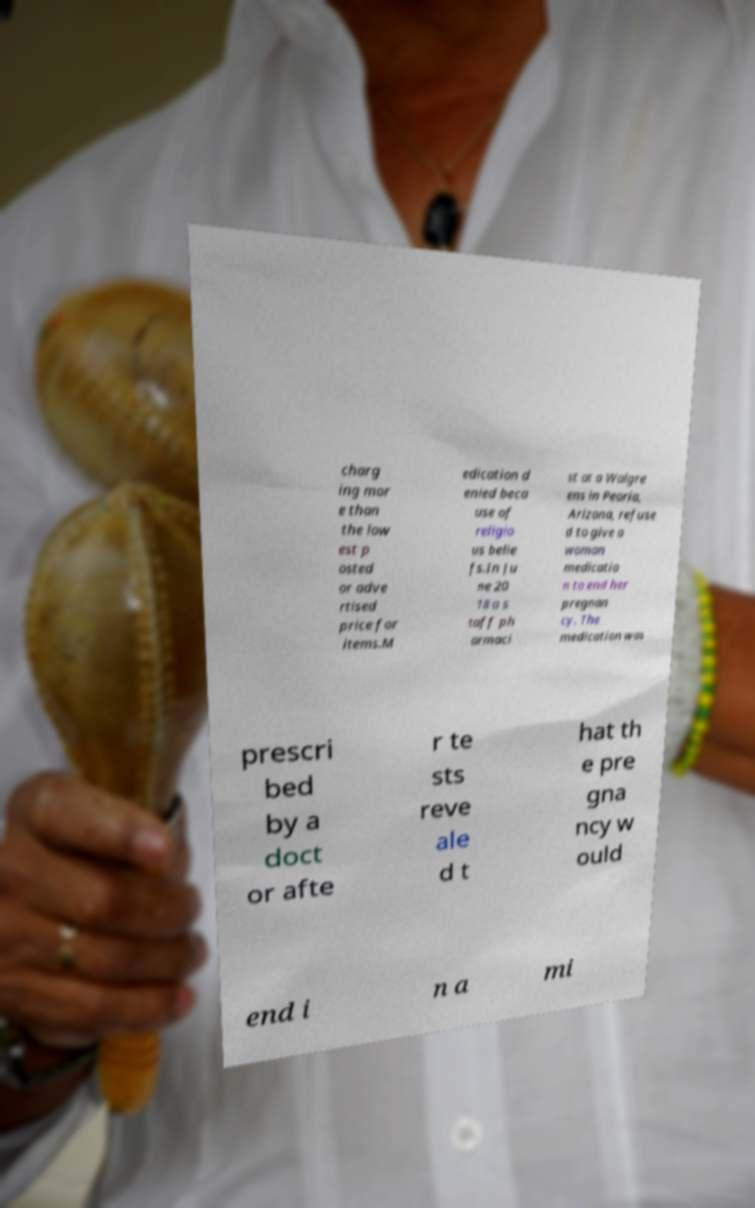What messages or text are displayed in this image? I need them in a readable, typed format. charg ing mor e than the low est p osted or adve rtised price for items.M edication d enied beca use of religio us belie fs.In Ju ne 20 18 a s taff ph armaci st at a Walgre ens in Peoria, Arizona, refuse d to give a woman medicatio n to end her pregnan cy. The medication was prescri bed by a doct or afte r te sts reve ale d t hat th e pre gna ncy w ould end i n a mi 